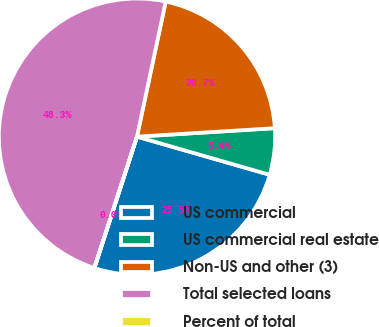<chart> <loc_0><loc_0><loc_500><loc_500><pie_chart><fcel>US commercial<fcel>US commercial real estate<fcel>Non-US and other (3)<fcel>Total selected loans<fcel>Percent of total<nl><fcel>25.53%<fcel>5.43%<fcel>20.69%<fcel>48.34%<fcel>0.02%<nl></chart> 